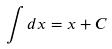Convert formula to latex. <formula><loc_0><loc_0><loc_500><loc_500>\int d x = x + C</formula> 